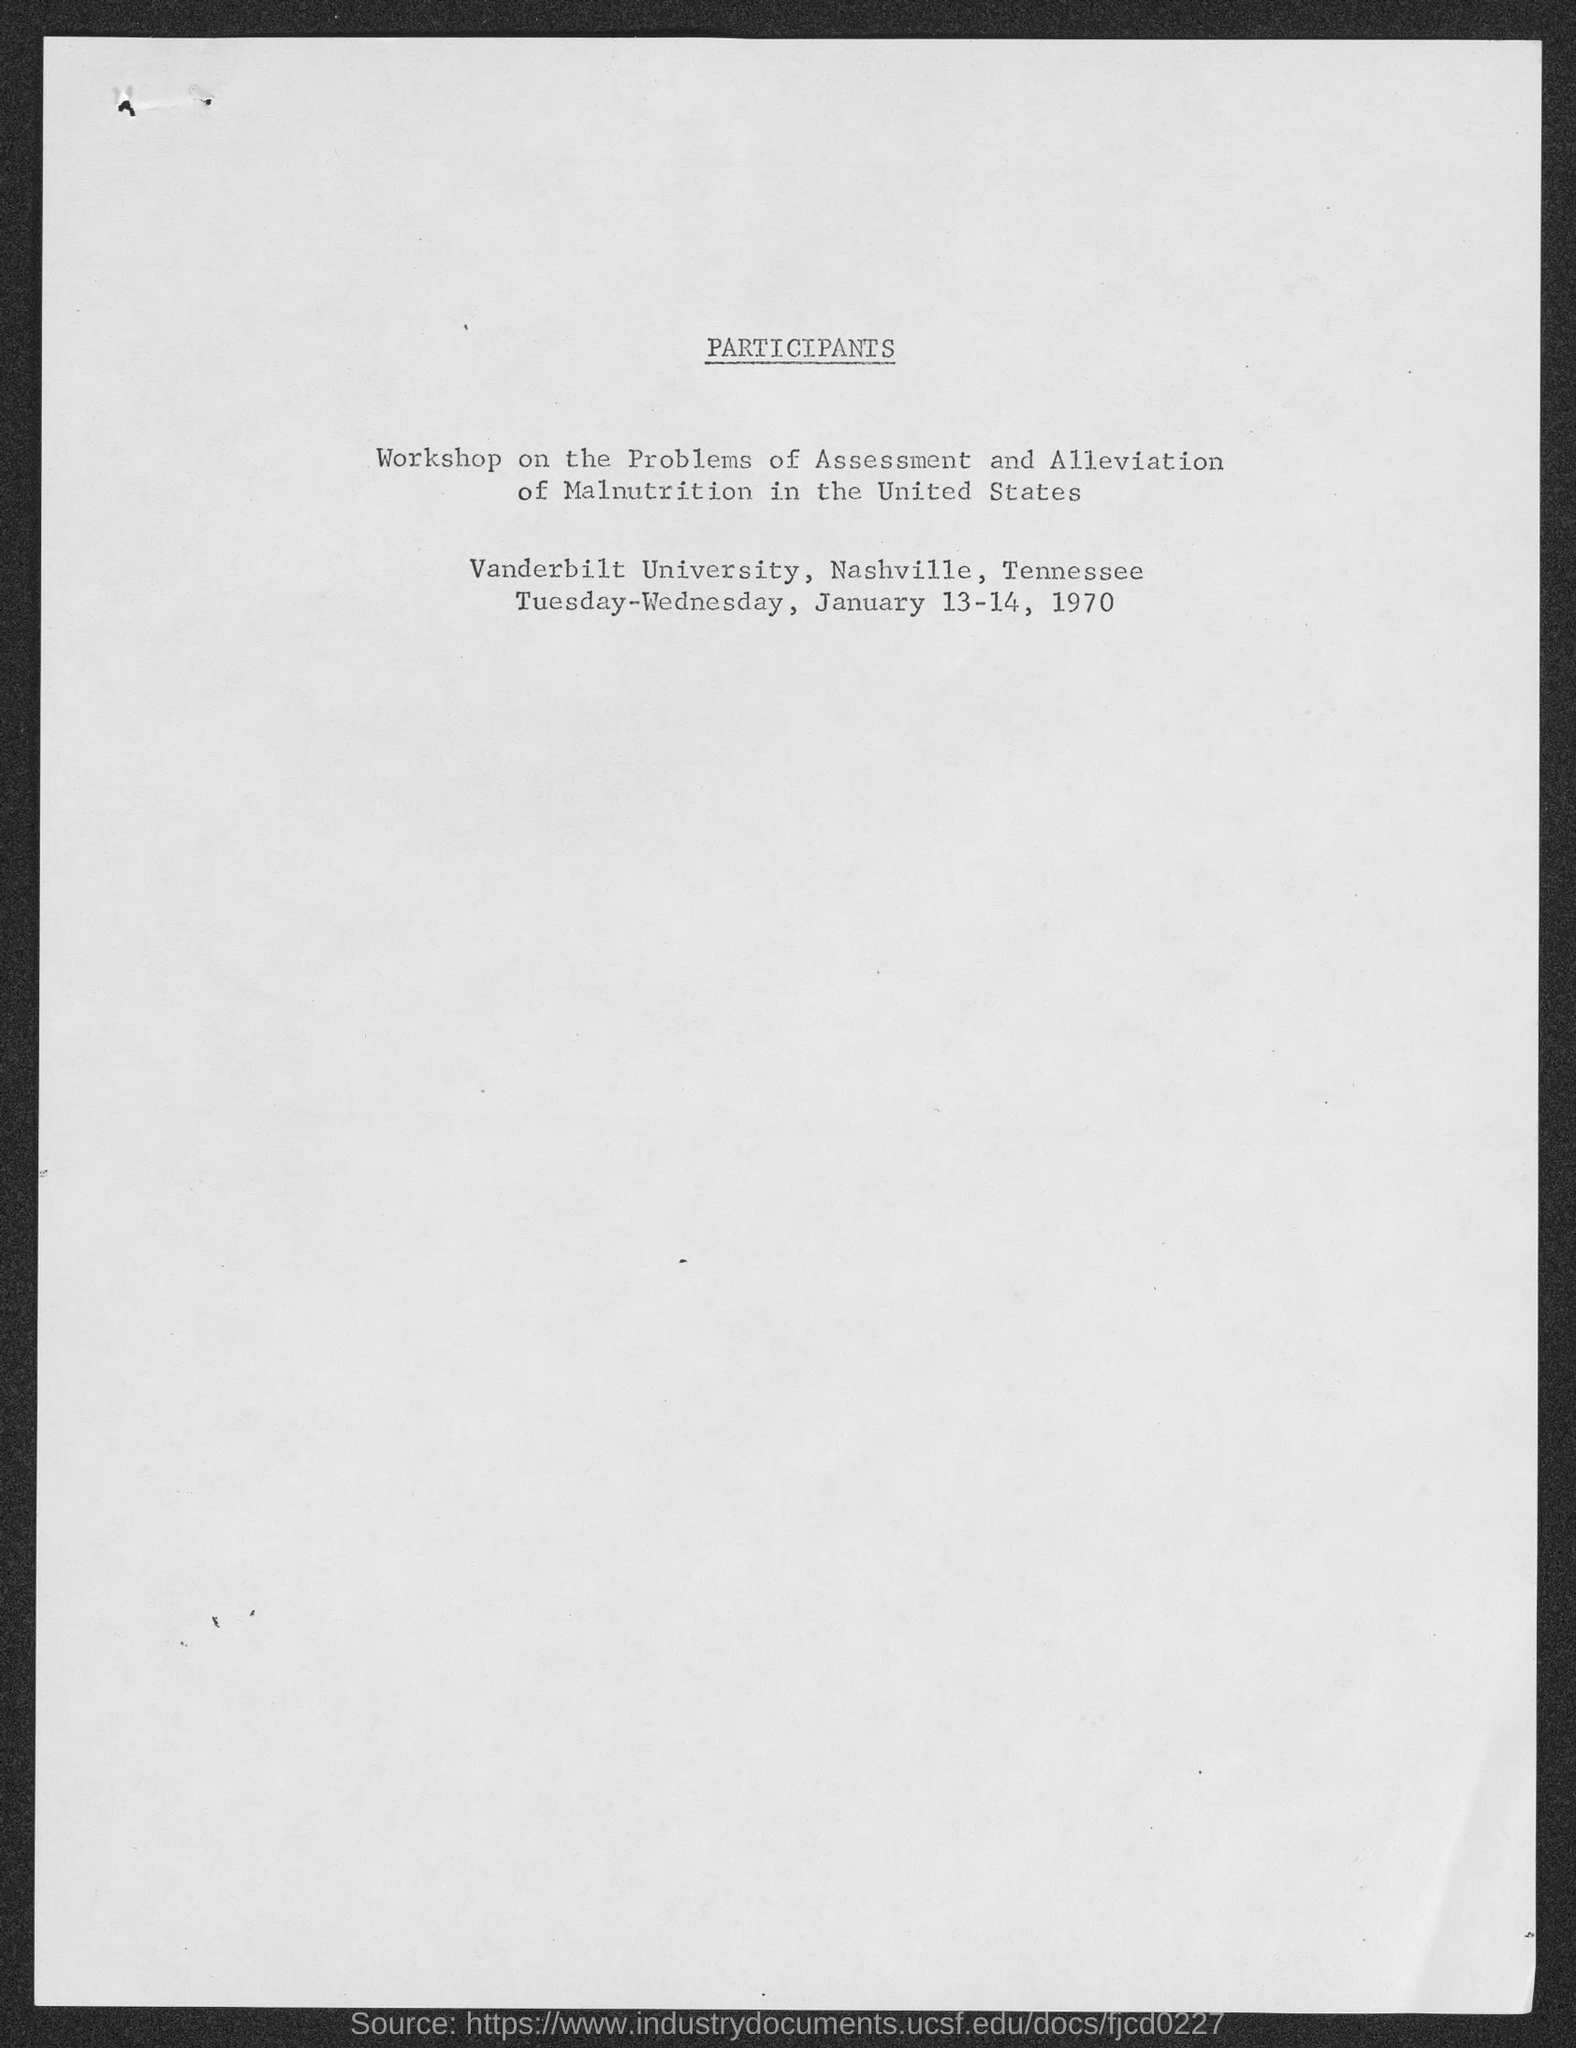Specify some key components in this picture. The workshop on the problems of assessment and alleviation of malnutrition in the United States was held at Vanderbilt University in Nashville, Tennessee. 